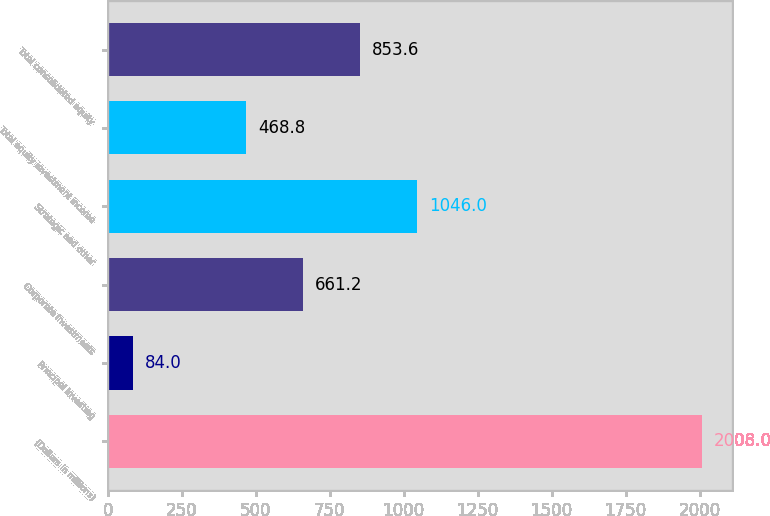<chart> <loc_0><loc_0><loc_500><loc_500><bar_chart><fcel>(Dollars in millions)<fcel>Principal Investing<fcel>Corporate Investments<fcel>Strategic and other<fcel>Total equity investment income<fcel>Total consolidated equity<nl><fcel>2008<fcel>84<fcel>661.2<fcel>1046<fcel>468.8<fcel>853.6<nl></chart> 